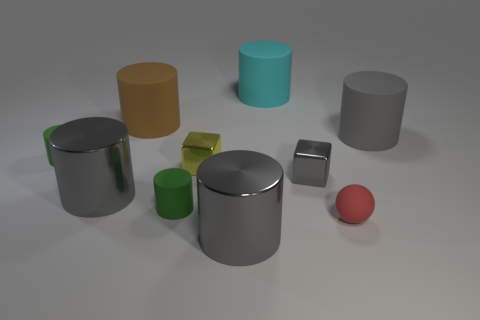What number of metallic cylinders have the same size as the yellow object?
Provide a succinct answer. 0. The red object is what size?
Make the answer very short. Small. How many cyan rubber things are behind the large cyan rubber cylinder?
Provide a succinct answer. 0. What shape is the tiny red thing that is made of the same material as the cyan cylinder?
Offer a very short reply. Sphere. Is the number of tiny green matte things that are on the right side of the large cyan cylinder less than the number of big gray shiny things that are left of the tiny yellow thing?
Provide a short and direct response. Yes. Is the number of cyan matte cylinders greater than the number of gray metal objects?
Provide a succinct answer. No. What is the material of the big brown thing?
Your response must be concise. Rubber. What color is the large shiny thing that is in front of the red sphere?
Your answer should be compact. Gray. Are there more green matte things that are in front of the tiny gray cube than yellow things that are left of the large brown cylinder?
Ensure brevity in your answer.  Yes. What size is the shiny cylinder behind the small cylinder that is in front of the tiny block that is right of the cyan cylinder?
Your response must be concise. Large. 